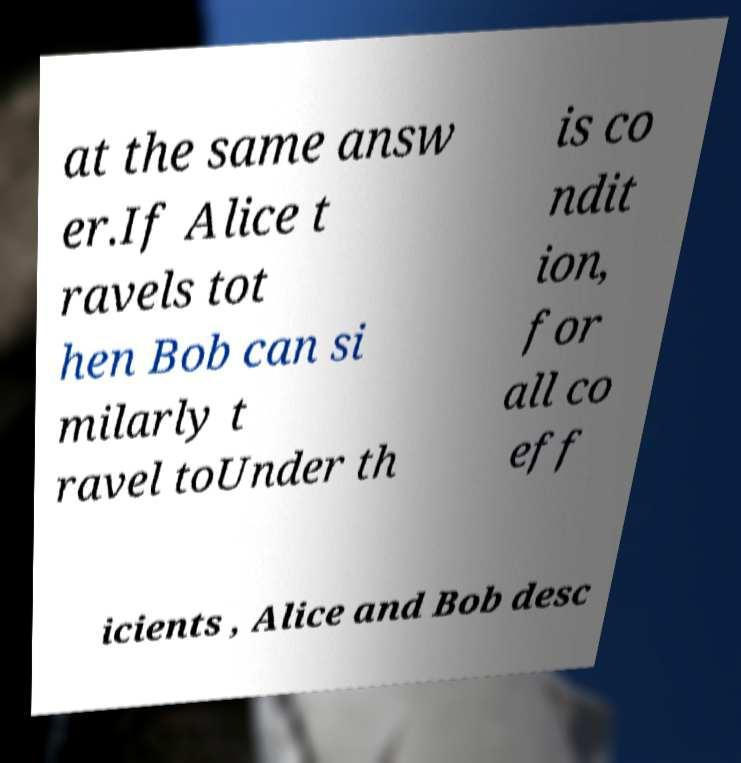Could you assist in decoding the text presented in this image and type it out clearly? at the same answ er.If Alice t ravels tot hen Bob can si milarly t ravel toUnder th is co ndit ion, for all co eff icients , Alice and Bob desc 